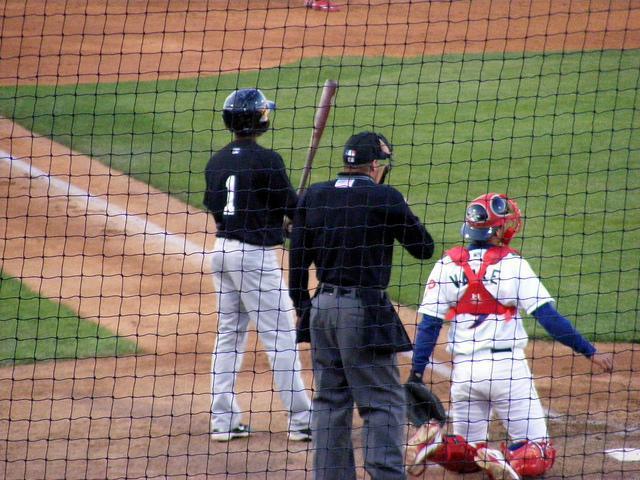How many people are in the photo?
Give a very brief answer. 4. How many toothbrushes are in this image?
Give a very brief answer. 0. 